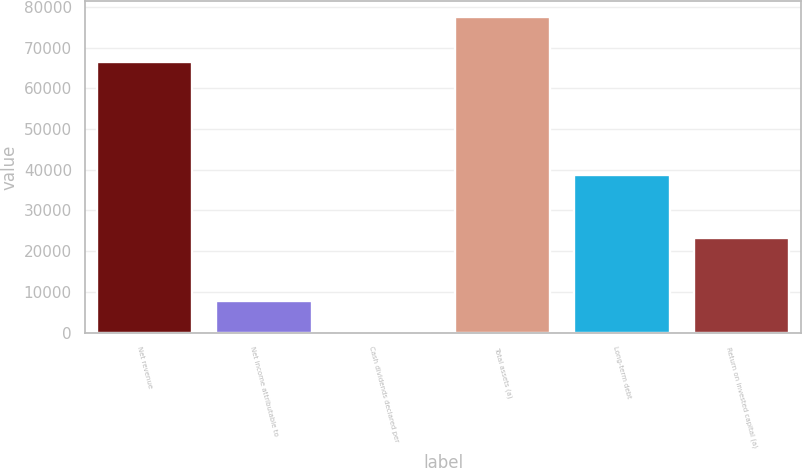<chart> <loc_0><loc_0><loc_500><loc_500><bar_chart><fcel>Net revenue<fcel>Net income attributable to<fcel>Cash dividends declared per<fcel>Total assets (a)<fcel>Long-term debt<fcel>Return on invested capital (a)<nl><fcel>66415<fcel>7749.82<fcel>2.24<fcel>77478<fcel>38740.1<fcel>23245<nl></chart> 